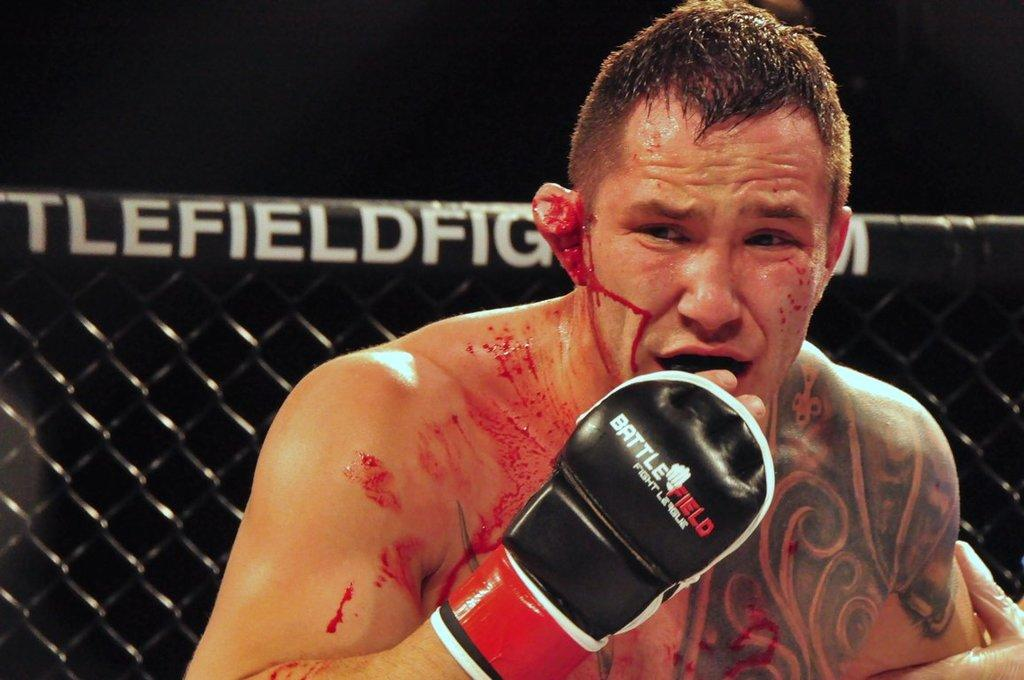What is the main subject of the image? There is a person in the image. What is the condition of the person in the image? The person is bleeding. What is the person wearing on their hand? The person is wearing a black, red, and white colored glove. What can be seen in the background of the image? There is a black colored metal fence in the image, and the background is dark. Can you see the tiger's eyes in the image? There is no tiger present in the image, so it is not possible to see the tiger's eyes. 